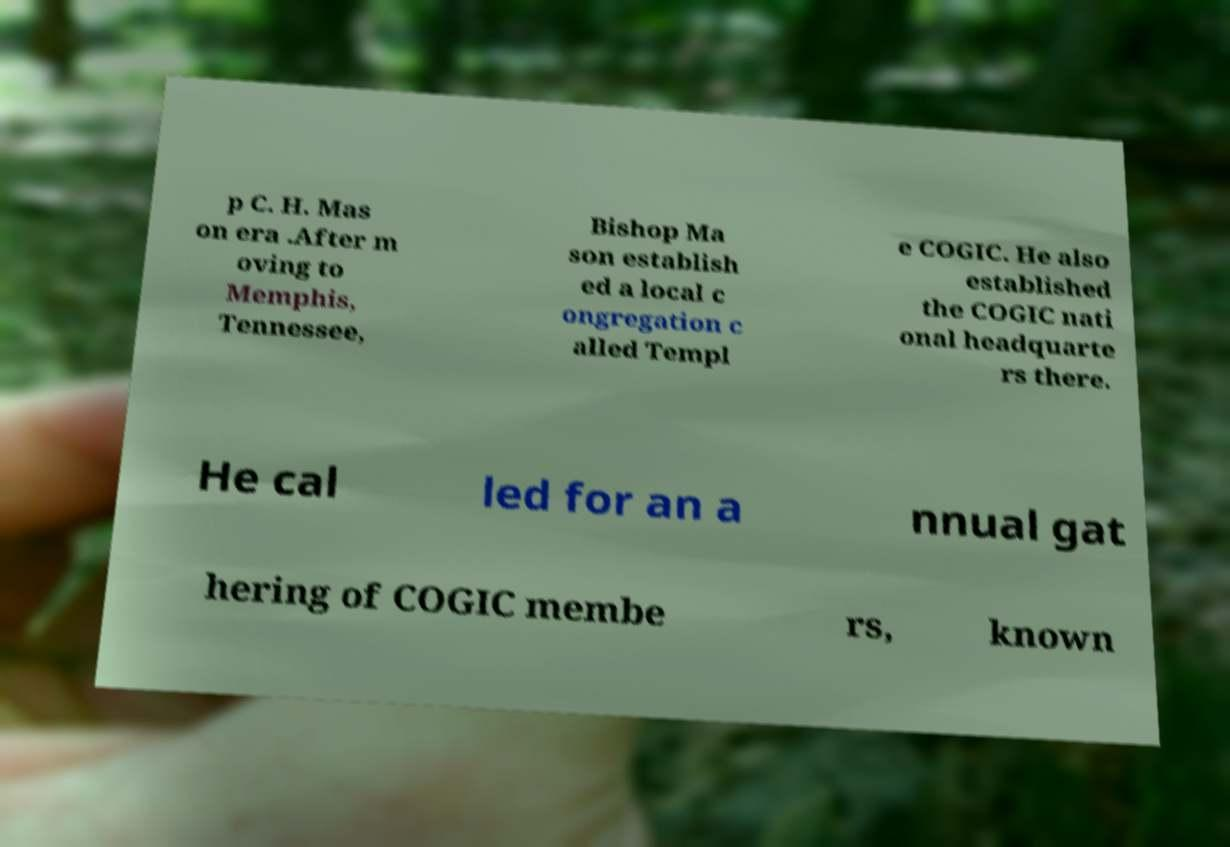There's text embedded in this image that I need extracted. Can you transcribe it verbatim? p C. H. Mas on era .After m oving to Memphis, Tennessee, Bishop Ma son establish ed a local c ongregation c alled Templ e COGIC. He also established the COGIC nati onal headquarte rs there. He cal led for an a nnual gat hering of COGIC membe rs, known 